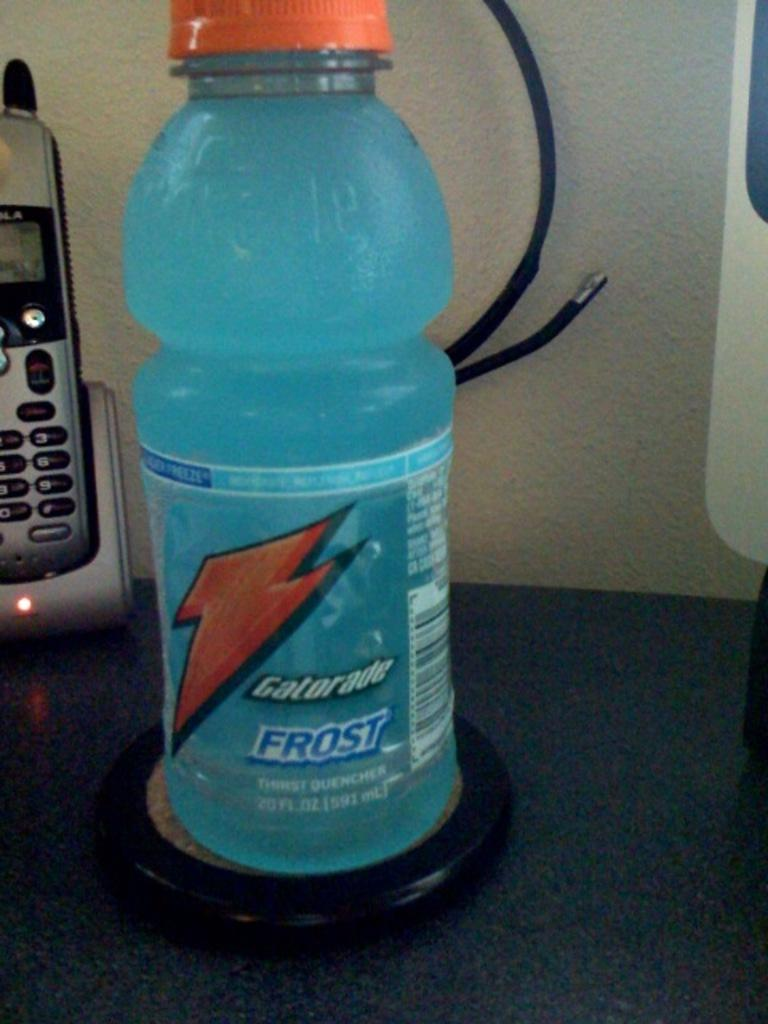<image>
Create a compact narrative representing the image presented. A cold unopened bottle of Gatorade Frost sitting on a coaster next to a cordless home phone sitting on a charger. 